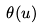<formula> <loc_0><loc_0><loc_500><loc_500>\theta ( u )</formula> 